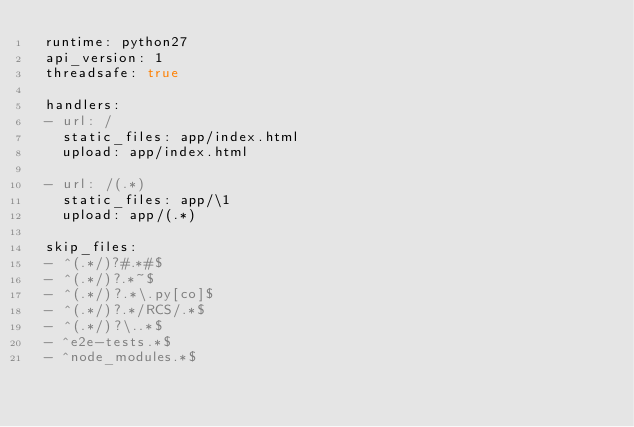Convert code to text. <code><loc_0><loc_0><loc_500><loc_500><_YAML_> runtime: python27
 api_version: 1
 threadsafe: true

 handlers:
 - url: /
   static_files: app/index.html
   upload: app/index.html

 - url: /(.*)
   static_files: app/\1
   upload: app/(.*)

 skip_files:
 - ^(.*/)?#.*#$
 - ^(.*/)?.*~$
 - ^(.*/)?.*\.py[co]$
 - ^(.*/)?.*/RCS/.*$
 - ^(.*/)?\..*$
 - ^e2e-tests.*$
 - ^node_modules.*$


</code> 